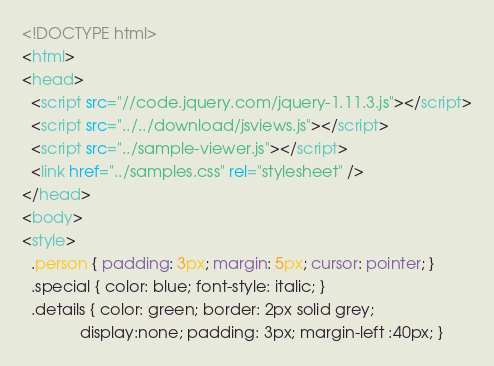Convert code to text. <code><loc_0><loc_0><loc_500><loc_500><_HTML_><!DOCTYPE html>
<html>
<head>
  <script src="//code.jquery.com/jquery-1.11.3.js"></script>
  <script src="../../download/jsviews.js"></script>
  <script src="../sample-viewer.js"></script>
  <link href="../samples.css" rel="stylesheet" />
</head>
<body>
<style>
  .person { padding: 3px; margin: 5px; cursor: pointer; }
  .special { color: blue; font-style: italic; }
  .details { color: green; border: 2px solid grey;
             display:none; padding: 3px; margin-left :40px; }</code> 